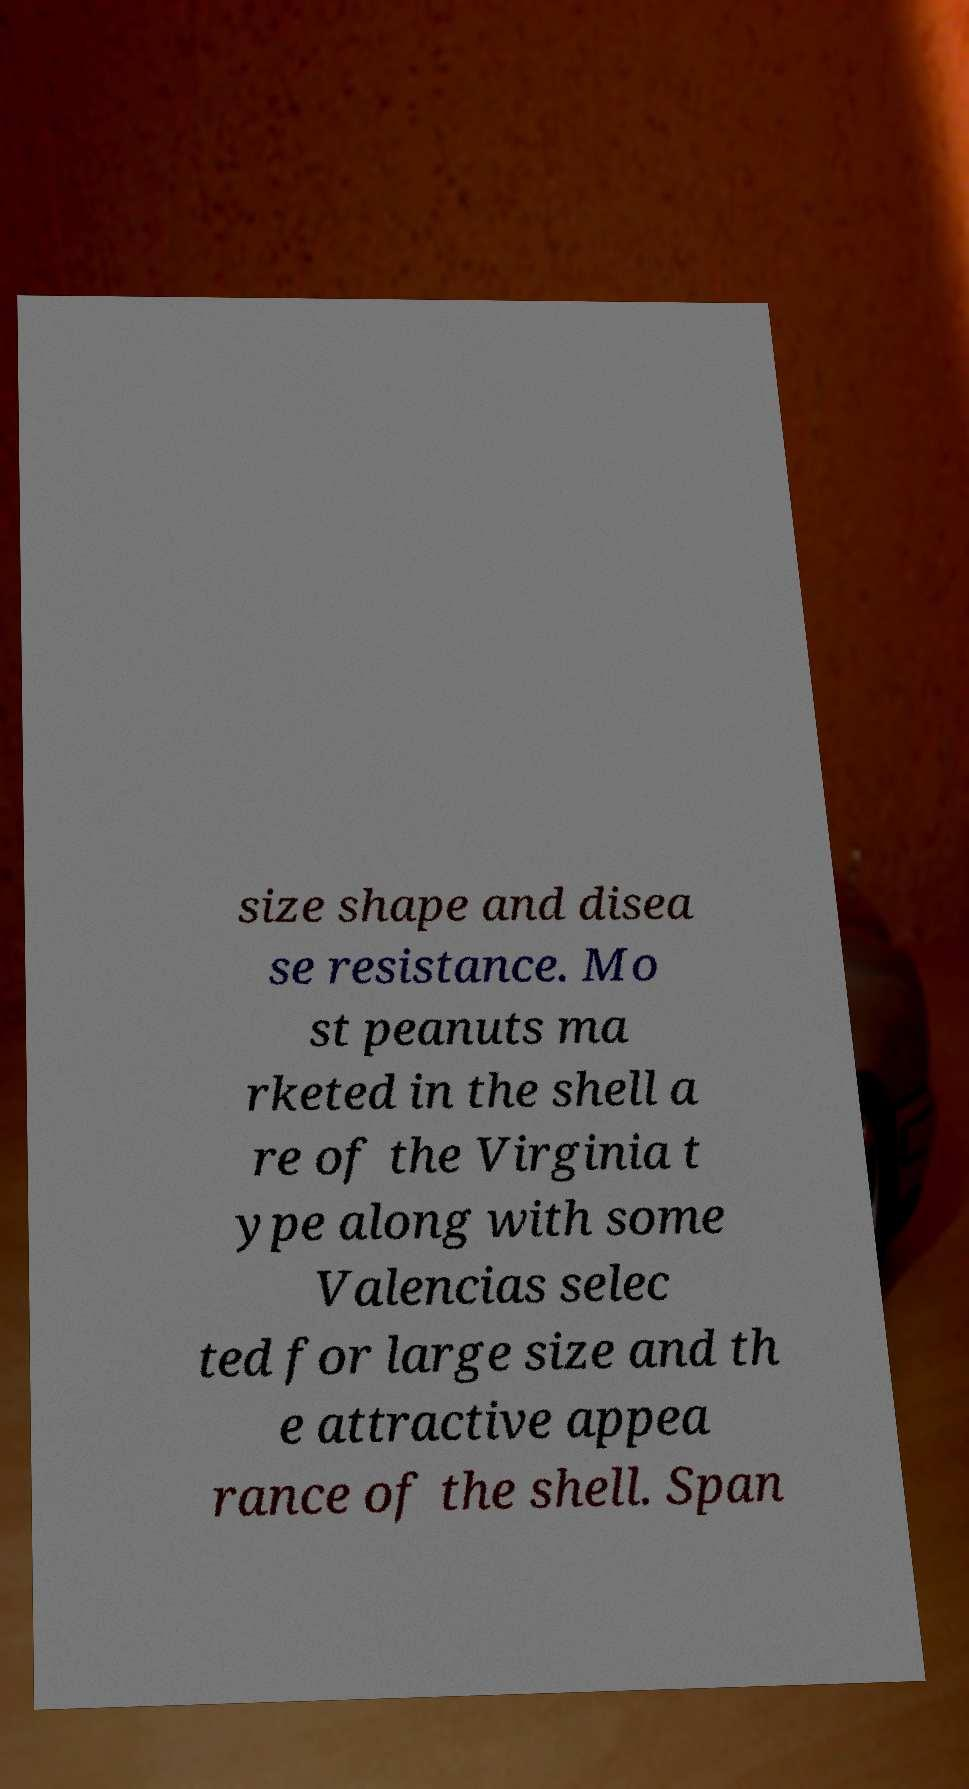Please identify and transcribe the text found in this image. size shape and disea se resistance. Mo st peanuts ma rketed in the shell a re of the Virginia t ype along with some Valencias selec ted for large size and th e attractive appea rance of the shell. Span 